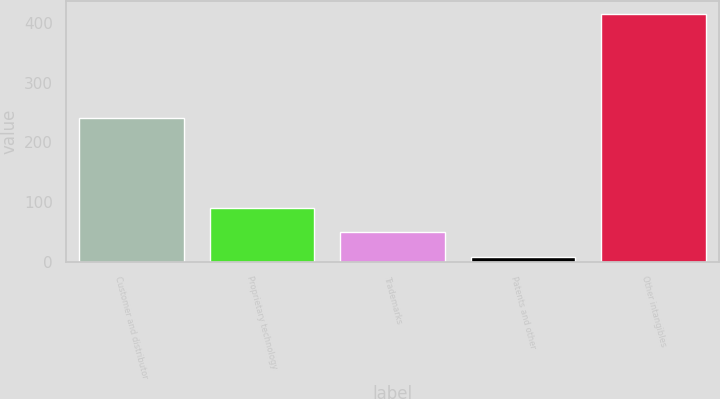Convert chart. <chart><loc_0><loc_0><loc_500><loc_500><bar_chart><fcel>Customer and distributor<fcel>Proprietary technology<fcel>Trademarks<fcel>Patents and other<fcel>Other intangibles<nl><fcel>241<fcel>89.6<fcel>48.8<fcel>8<fcel>416<nl></chart> 